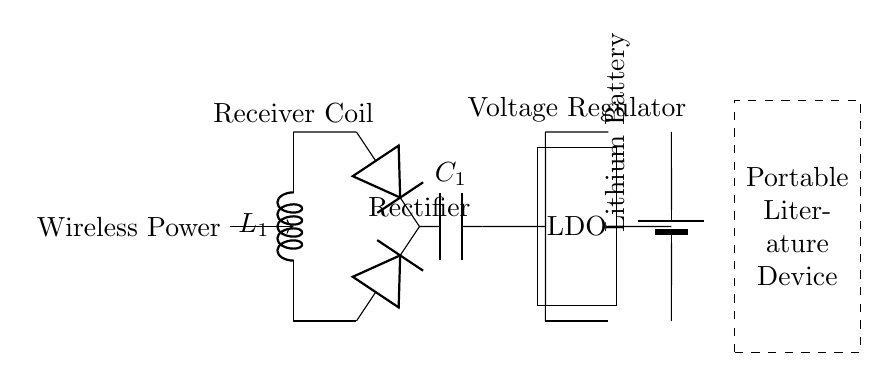What is the primary function of the receiver coil? The receiver coil's primary function is to capture the wireless power transmitted to it. It converts the electromagnetic energy into electrical energy to power the circuit.
Answer: Capture wireless power What is the component used for converting AC to DC? The component used for converting alternating current to direct current in this circuit is the diode, which allows current to flow in one direction only.
Answer: Diode How many capacitors are shown in the circuit? There is one capacitor labeled C1 in the circuit, which is used to smooth out the voltage after rectification.
Answer: One What type of battery is indicated in the circuit? The circuit indicates a lithium battery, which is commonly used in portable devices due to its high energy density.
Answer: Lithium Battery What is the role of the voltage regulator in this circuit? The voltage regulator's role is to maintain a consistent output voltage, ensuring that the portable literature device receives stable power despite variations in input voltage.
Answer: Maintain consistent voltage What component connects the rectifier to the voltage regulator? The short connection between the rectifier and the voltage regulator signifies that the output from the rectifier is directly supplied to the voltage regulator for further processing.
Answer: Short What type of circuit is represented by this diagram? This circuit represents a wireless charging system, which uses magnetic fields to transfer energy for powering devices without direct connections.
Answer: Wireless charging system 